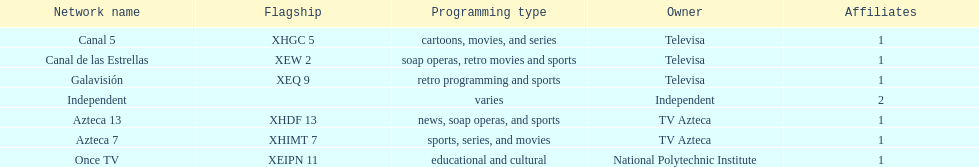How many networks does televisa own? 3. 